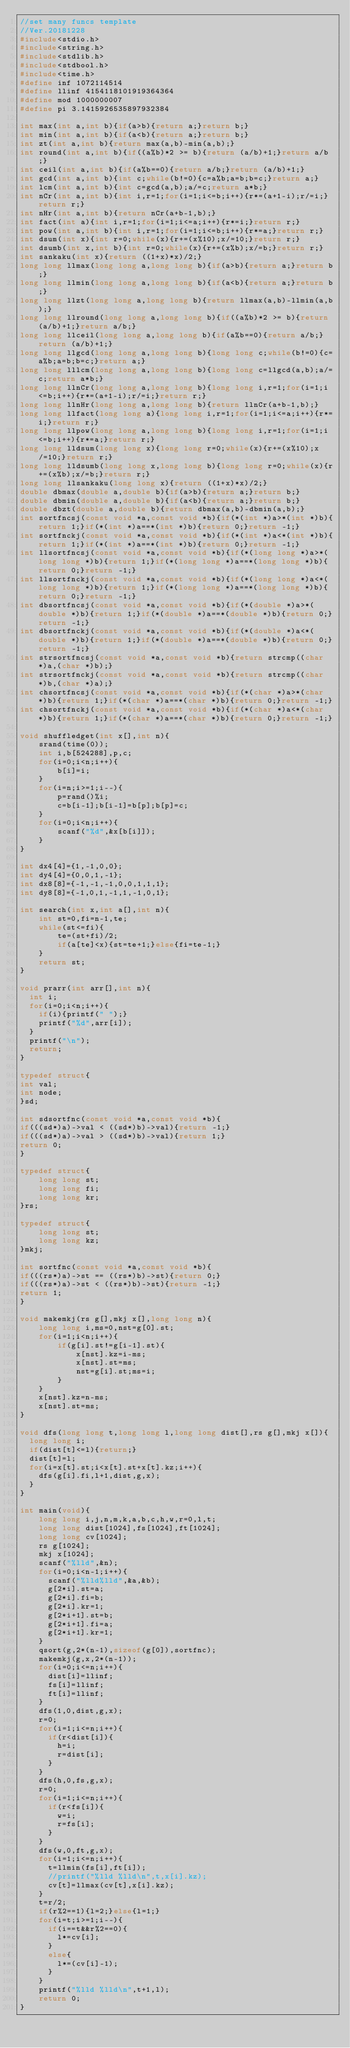<code> <loc_0><loc_0><loc_500><loc_500><_C_>//set many funcs template
//Ver.20181228
#include<stdio.h>
#include<string.h>
#include<stdlib.h>
#include<stdbool.h>
#include<time.h>
#define inf 1072114514
#define llinf 4154118101919364364
#define mod 1000000007
#define pi 3.1415926535897932384

int max(int a,int b){if(a>b){return a;}return b;}
int min(int a,int b){if(a<b){return a;}return b;}
int zt(int a,int b){return max(a,b)-min(a,b);}
int round(int a,int b){if((a%b)*2 >= b){return (a/b)+1;}return a/b;}
int ceil(int a,int b){if(a%b==0){return a/b;}return (a/b)+1;}
int gcd(int a,int b){int c;while(b!=0){c=a%b;a=b;b=c;}return a;}
int lcm(int a,int b){int c=gcd(a,b);a/=c;return a*b;}
int nCr(int a,int b){int i,r=1;for(i=1;i<=b;i++){r*=(a+1-i);r/=i;}return r;}
int nHr(int a,int b){return nCr(a+b-1,b);}
int fact(int a){int i,r=1;for(i=1;i<=a;i++){r*=i;}return r;}
int pow(int a,int b){int i,r=1;for(i=1;i<=b;i++){r*=a;}return r;}
int dsum(int x){int r=0;while(x){r+=(x%10);x/=10;}return r;}
int dsumb(int x,int b){int r=0;while(x){r+=(x%b);x/=b;}return r;}
int sankaku(int x){return ((1+x)*x)/2;}
long long llmax(long long a,long long b){if(a>b){return a;}return b;}
long long llmin(long long a,long long b){if(a<b){return a;}return b;}
long long llzt(long long a,long long b){return llmax(a,b)-llmin(a,b);}
long long llround(long long a,long long b){if((a%b)*2 >= b){return (a/b)+1;}return a/b;}
long long llceil(long long a,long long b){if(a%b==0){return a/b;}return (a/b)+1;}
long long llgcd(long long a,long long b){long long c;while(b!=0){c=a%b;a=b;b=c;}return a;}
long long lllcm(long long a,long long b){long long c=llgcd(a,b);a/=c;return a*b;}
long long llnCr(long long a,long long b){long long i,r=1;for(i=1;i<=b;i++){r*=(a+1-i);r/=i;}return r;}
long long llnHr(long long a,long long b){return llnCr(a+b-1,b);}
long long llfact(long long a){long long i,r=1;for(i=1;i<=a;i++){r*=i;}return r;}
long long llpow(long long a,long long b){long long i,r=1;for(i=1;i<=b;i++){r*=a;}return r;}
long long lldsum(long long x){long long r=0;while(x){r+=(x%10);x/=10;}return r;}
long long lldsumb(long long x,long long b){long long r=0;while(x){r+=(x%b);x/=b;}return r;}
long long llsankaku(long long x){return ((1+x)*x)/2;}
double dbmax(double a,double b){if(a>b){return a;}return b;}
double dbmin(double a,double b){if(a<b){return a;}return b;}
double dbzt(double a,double b){return dbmax(a,b)-dbmin(a,b);}
int sortfncsj(const void *a,const void *b){if(*(int *)a>*(int *)b){return 1;}if(*(int *)a==*(int *)b){return 0;}return -1;}
int sortfnckj(const void *a,const void *b){if(*(int *)a<*(int *)b){return 1;}if(*(int *)a==*(int *)b){return 0;}return -1;}
int llsortfncsj(const void *a,const void *b){if(*(long long *)a>*(long long *)b){return 1;}if(*(long long *)a==*(long long *)b){return 0;}return -1;}
int llsortfnckj(const void *a,const void *b){if(*(long long *)a<*(long long *)b){return 1;}if(*(long long *)a==*(long long *)b){return 0;}return -1;}
int dbsortfncsj(const void *a,const void *b){if(*(double *)a>*(double *)b){return 1;}if(*(double *)a==*(double *)b){return 0;}return -1;}
int dbsortfnckj(const void *a,const void *b){if(*(double *)a<*(double *)b){return 1;}if(*(double *)a==*(double *)b){return 0;}return -1;}
int strsortfncsj(const void *a,const void *b){return strcmp((char *)a,(char *)b);}
int strsortfnckj(const void *a,const void *b){return strcmp((char *)b,(char *)a);}
int chsortfncsj(const void *a,const void *b){if(*(char *)a>*(char *)b){return 1;}if(*(char *)a==*(char *)b){return 0;}return -1;}
int chsortfnckj(const void *a,const void *b){if(*(char *)a<*(char *)b){return 1;}if(*(char *)a==*(char *)b){return 0;}return -1;}

void shuffledget(int x[],int n){
    srand(time(0));
    int i,b[524288],p,c;
    for(i=0;i<n;i++){
        b[i]=i;
    }
    for(i=n;i>=1;i--){
        p=rand()%i;
        c=b[i-1];b[i-1]=b[p];b[p]=c;
    }
    for(i=0;i<n;i++){
        scanf("%d",&x[b[i]]);
    }
}

int dx4[4]={1,-1,0,0};
int dy4[4]={0,0,1,-1};
int dx8[8]={-1,-1,-1,0,0,1,1,1};
int dy8[8]={-1,0,1,-1,1,-1,0,1};

int search(int x,int a[],int n){
    int st=0,fi=n-1,te;
    while(st<=fi){
        te=(st+fi)/2;
        if(a[te]<x){st=te+1;}else{fi=te-1;}
    }
    return st;
}

void prarr(int arr[],int n){
  int i;
  for(i=0;i<n;i++){
    if(i){printf(" ");}
    printf("%d",arr[i]);
  }
  printf("\n");
  return;
}

typedef struct{
int val;
int node;
}sd;

int sdsortfnc(const void *a,const void *b){
if(((sd*)a)->val < ((sd*)b)->val){return -1;}
if(((sd*)a)->val > ((sd*)b)->val){return 1;}
return 0;
}

typedef struct{
    long long st;
    long long fi;
    long long kr;
}rs;

typedef struct{
    long long st;
    long long kz;
}mkj;

int sortfnc(const void *a,const void *b){
if(((rs*)a)->st == ((rs*)b)->st){return 0;}
if(((rs*)a)->st < ((rs*)b)->st){return -1;}
return 1;
}

void makemkj(rs g[],mkj x[],long long n){
    long long i,ms=0,nst=g[0].st;
    for(i=1;i<n;i++){
        if(g[i].st!=g[i-1].st){
            x[nst].kz=i-ms;
            x[nst].st=ms;
            nst=g[i].st;ms=i;
        }
    }
    x[nst].kz=n-ms;
    x[nst].st=ms;
}

void dfs(long long t,long long l,long long dist[],rs g[],mkj x[]){
  long long i;
  if(dist[t]<=l){return;}
  dist[t]=l;
  for(i=x[t].st;i<x[t].st+x[t].kz;i++){
    dfs(g[i].fi,l+1,dist,g,x);
  }
}

int main(void){
    long long i,j,n,m,k,a,b,c,h,w,r=0,l,t;
    long long dist[1024],fs[1024],ft[1024];
    long long cv[1024];
    rs g[1024];
    mkj x[1024];
    scanf("%lld",&n);
    for(i=0;i<n-1;i++){
      scanf("%lld%lld",&a,&b);
      g[2*i].st=a;
      g[2*i].fi=b;
      g[2*i].kr=1;
      g[2*i+1].st=b;
      g[2*i+1].fi=a;
      g[2*i+1].kr=1;
    }
    qsort(g,2*(n-1),sizeof(g[0]),sortfnc);
    makemkj(g,x,2*(n-1));
    for(i=0;i<=n;i++){
      dist[i]=llinf;
      fs[i]=llinf;
      ft[i]=llinf;
    }
    dfs(1,0,dist,g,x);
    r=0;
    for(i=1;i<=n;i++){
      if(r<dist[i]){
        h=i;
        r=dist[i];
      }
    }
    dfs(h,0,fs,g,x);
    r=0;
    for(i=1;i<=n;i++){
      if(r<fs[i]){
        w=i;
        r=fs[i];
      }
    }
    dfs(w,0,ft,g,x);
    for(i=1;i<=n;i++){
      t=llmin(fs[i],ft[i]);
      //printf("%lld %lld\n",t,x[i].kz);
      cv[t]=llmax(cv[t],x[i].kz);
    }
    t=r/2;
    if(r%2==1){l=2;}else{l=1;}
    for(i=t;i>=1;i--){
      if(i==t&&r%2==0){
        l*=cv[i];
      }
      else{
        l*=(cv[i]-1);
      }
    }
    printf("%lld %lld\n",t+1,l);
    return 0;
}</code> 